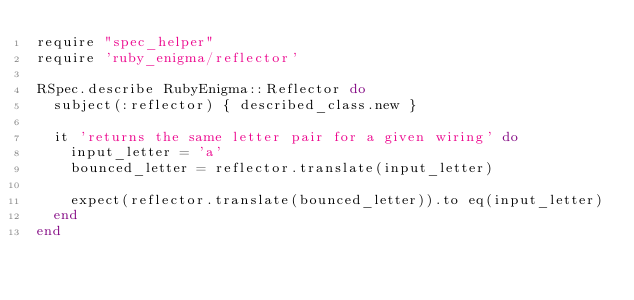<code> <loc_0><loc_0><loc_500><loc_500><_Ruby_>require "spec_helper"
require 'ruby_enigma/reflector'

RSpec.describe RubyEnigma::Reflector do
  subject(:reflector) { described_class.new }

  it 'returns the same letter pair for a given wiring' do
    input_letter = 'a'
    bounced_letter = reflector.translate(input_letter)

    expect(reflector.translate(bounced_letter)).to eq(input_letter)
  end
end
</code> 